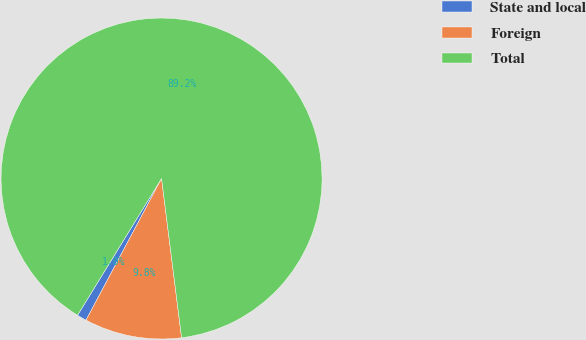<chart> <loc_0><loc_0><loc_500><loc_500><pie_chart><fcel>State and local<fcel>Foreign<fcel>Total<nl><fcel>0.97%<fcel>9.79%<fcel>89.24%<nl></chart> 